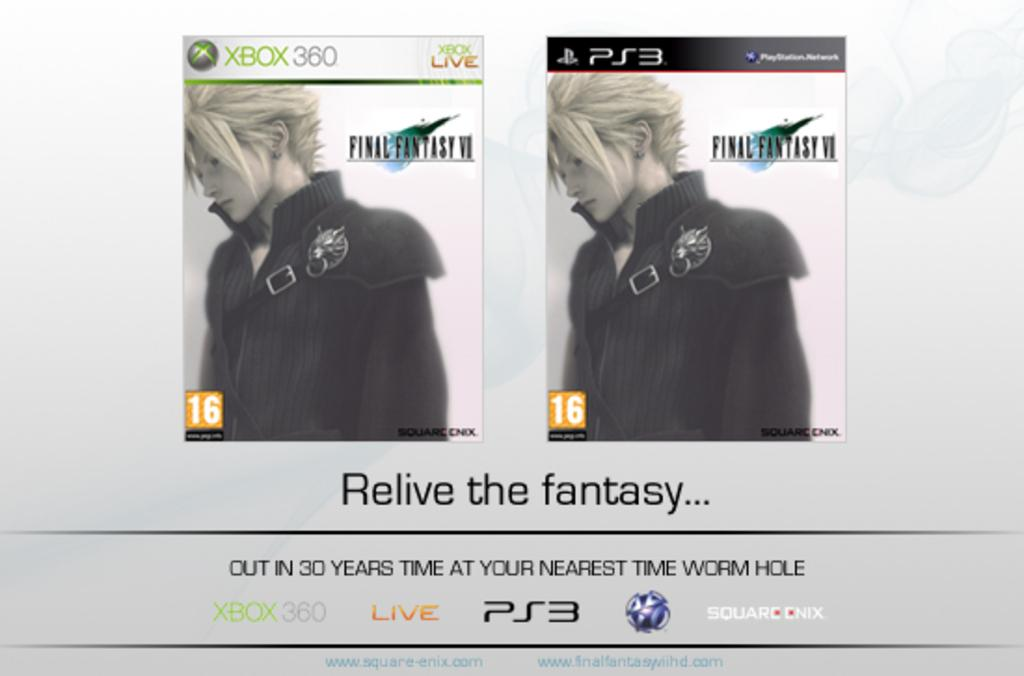What object is featured in the image? There is a compact disk cover in the image. What is depicted on the compact disk cover? The compact disk cover has a picture of a person. Are there any words on the compact disk cover? Yes, there is text on the compact disk cover. Is there any text outside of the compact disk cover in the image? Yes, there is text at the bottom of the image. What is the person in the picture wearing? The person in the picture is wearing a black top. Can you tell me how many dogs are visible in the image? There are no dogs present in the image. The image features a compact disk cover with a picture of a person wearing a black top, and there is no mention of dogs or a sorting process. 